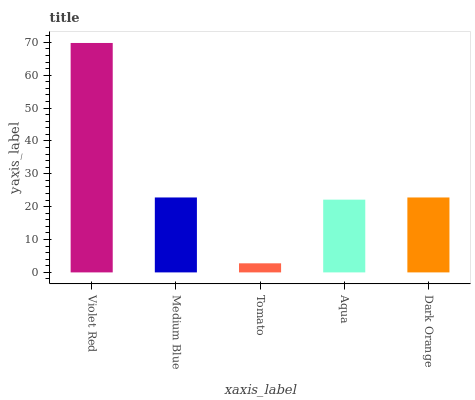Is Tomato the minimum?
Answer yes or no. Yes. Is Violet Red the maximum?
Answer yes or no. Yes. Is Medium Blue the minimum?
Answer yes or no. No. Is Medium Blue the maximum?
Answer yes or no. No. Is Violet Red greater than Medium Blue?
Answer yes or no. Yes. Is Medium Blue less than Violet Red?
Answer yes or no. Yes. Is Medium Blue greater than Violet Red?
Answer yes or no. No. Is Violet Red less than Medium Blue?
Answer yes or no. No. Is Dark Orange the high median?
Answer yes or no. Yes. Is Dark Orange the low median?
Answer yes or no. Yes. Is Aqua the high median?
Answer yes or no. No. Is Tomato the low median?
Answer yes or no. No. 